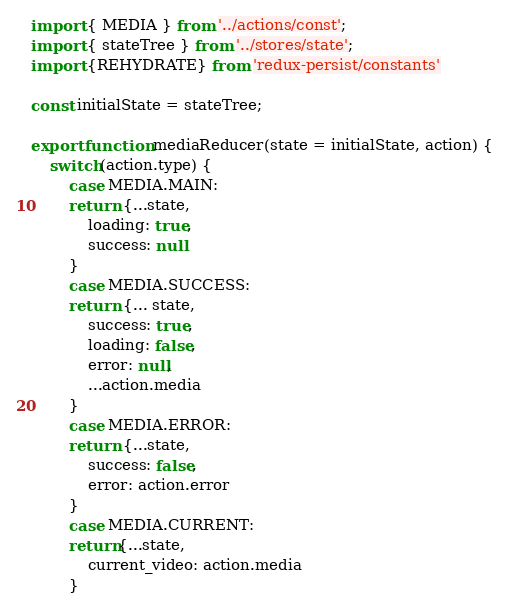<code> <loc_0><loc_0><loc_500><loc_500><_JavaScript_>import { MEDIA } from '../actions/const';
import { stateTree } from '../stores/state';
import {REHYDRATE} from 'redux-persist/constants'

const initialState = stateTree;

export function mediaReducer(state = initialState, action) {
    switch(action.type) {
        case MEDIA.MAIN:
        return {...state,
            loading: true,
            success: null
        }
        case MEDIA.SUCCESS:
        return {... state,
            success: true,
            loading: false,
            error: null,
            ...action.media
        }
        case MEDIA.ERROR:
        return {...state,
            success: false,
            error: action.error
        }
        case MEDIA.CURRENT:
        return{...state,
            current_video: action.media
        }</code> 